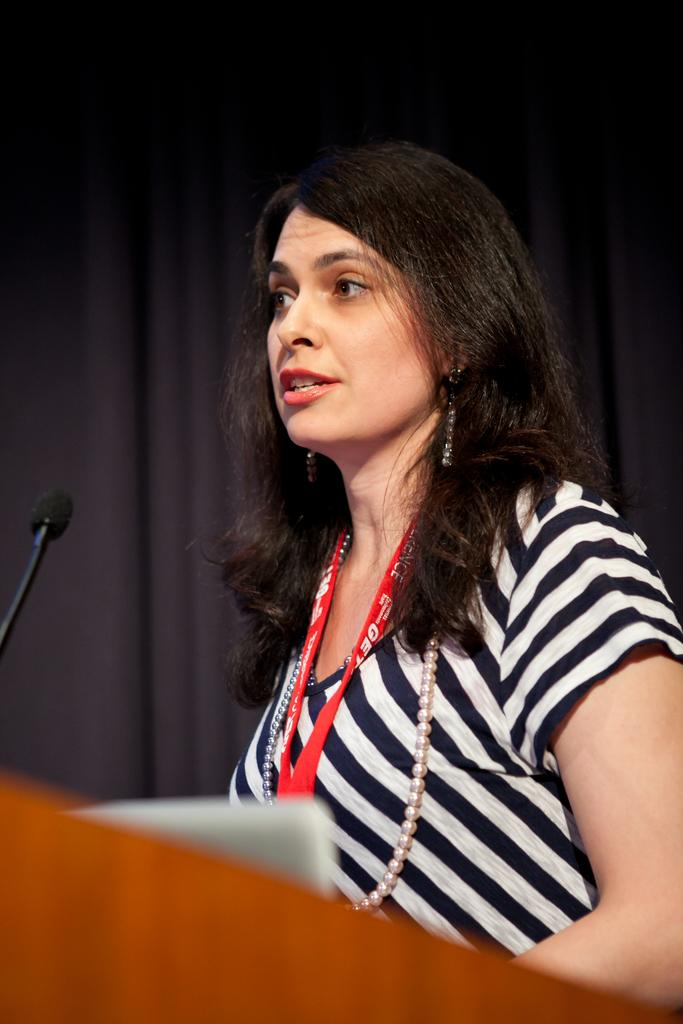What is the person in the image doing? The person is standing in front of the podium. What can be seen on the podium? There is a mic on the podium, as well as other objects. What is visible in the background of the image? There is a curtain in the background. What type of minister is present in the image? There is no mention of a minister in the image. --- Facts: 1. There is a person sitting on a chair. 2. The person is holding a book. 3. There is a table next to the chair. 4. There is a lamp on the table. Absurd Topics: elephant, parachute, ocean Conversation: What is the person in the image doing? The person is sitting on a chair and holding a book. What can be seen on the table next to the chair? There is a lamp on the table. How many items can be seen on the table? There is one item visible on the table, which is a lamp. Reasoning: Let's think step by step in order to produce the conversation. We start by identifying the main subject in the image, which is the person sitting on a chair. Then, we describe the action of the person, which is holding a book. Next, we observe the objects on the table next to the chair, which includes a lamp. Finally, we count the number of items visible on the table, which is one item. Absurd Question/Answer: Can you see an elephant or a parachute in the image? No, there is no elephant or parachute present in the image. --- Facts: 1. There is a person standing next to a bicycle. 2. The person is wearing a helmet. 3. The bicycle has two wheels. 4. There is a road visible in the background. Absurd Topics: giraffe, jungle, kangaroo Conversation: What is the person in the image doing? The person is standing next to a bicycle. What can be seen on the person's head? The person is wearing a helmet. How many wheels does the bicycle have? The bicycle has two wheels. What type of surface is visible in the background? There is a road visible in the background. Reasoning: Let's think step by step in order to produce the conversation. We start by identifying the main subject in the image, which is the person standing next to a bicycle. Then, we describe the action of the person, which is wearing a helmet. Next, we observe the objects related to the bicycle, which includes the number of wheels. Finally, we describe the background, which is a road. Absurd Question/Answer: Can you see a kangaroo or a jungle in the image? No, there is no kangaroo or jungle present in the image. 